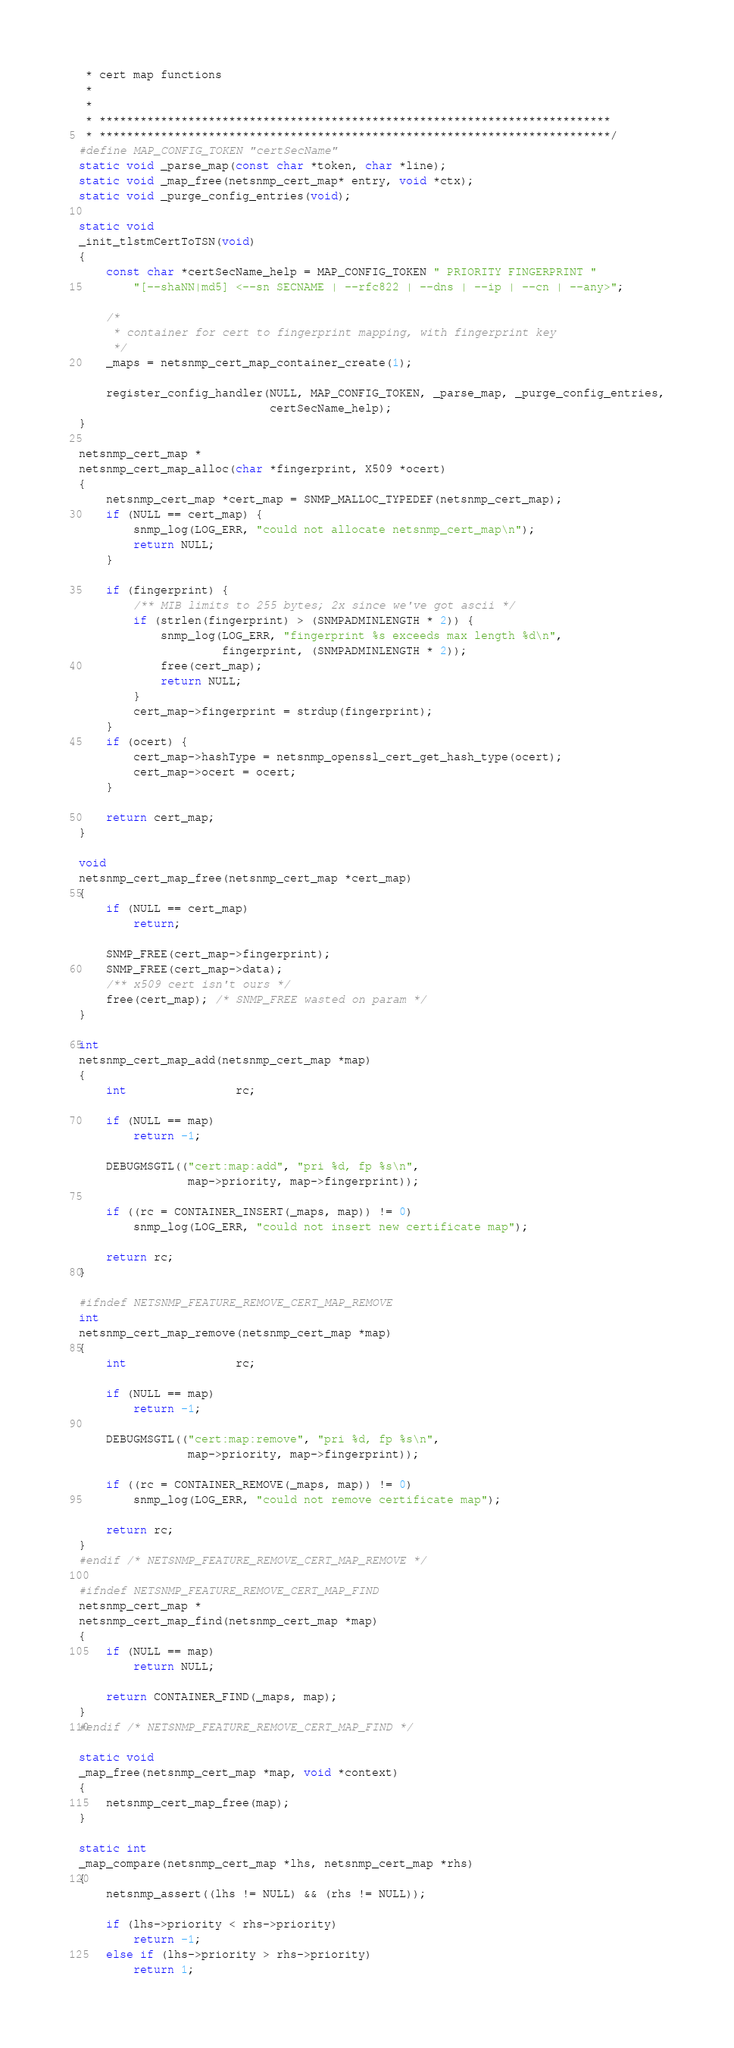Convert code to text. <code><loc_0><loc_0><loc_500><loc_500><_C_> * cert map functions
 *
 *
 * ***************************************************************************
 * ***************************************************************************/
#define MAP_CONFIG_TOKEN "certSecName"
static void _parse_map(const char *token, char *line);
static void _map_free(netsnmp_cert_map* entry, void *ctx);
static void _purge_config_entries(void);

static void
_init_tlstmCertToTSN(void)
{
    const char *certSecName_help = MAP_CONFIG_TOKEN " PRIORITY FINGERPRINT "
        "[--shaNN|md5] <--sn SECNAME | --rfc822 | --dns | --ip | --cn | --any>";

    /*
     * container for cert to fingerprint mapping, with fingerprint key
     */
    _maps = netsnmp_cert_map_container_create(1);

    register_config_handler(NULL, MAP_CONFIG_TOKEN, _parse_map, _purge_config_entries,
                            certSecName_help);
}

netsnmp_cert_map *
netsnmp_cert_map_alloc(char *fingerprint, X509 *ocert)
{
    netsnmp_cert_map *cert_map = SNMP_MALLOC_TYPEDEF(netsnmp_cert_map);
    if (NULL == cert_map) {
        snmp_log(LOG_ERR, "could not allocate netsnmp_cert_map\n");
        return NULL;
    }
    
    if (fingerprint) {
        /** MIB limits to 255 bytes; 2x since we've got ascii */
        if (strlen(fingerprint) > (SNMPADMINLENGTH * 2)) {
            snmp_log(LOG_ERR, "fingerprint %s exceeds max length %d\n",
                     fingerprint, (SNMPADMINLENGTH * 2));
            free(cert_map);
            return NULL;
        }
        cert_map->fingerprint = strdup(fingerprint);
    }
    if (ocert) {
        cert_map->hashType = netsnmp_openssl_cert_get_hash_type(ocert);
        cert_map->ocert = ocert;
    }

    return cert_map;
}

void
netsnmp_cert_map_free(netsnmp_cert_map *cert_map)
{
    if (NULL == cert_map)
        return;

    SNMP_FREE(cert_map->fingerprint);
    SNMP_FREE(cert_map->data);
    /** x509 cert isn't ours */
    free(cert_map); /* SNMP_FREE wasted on param */
}

int
netsnmp_cert_map_add(netsnmp_cert_map *map)
{
    int                rc;

    if (NULL == map)
        return -1;

    DEBUGMSGTL(("cert:map:add", "pri %d, fp %s\n",
                map->priority, map->fingerprint));

    if ((rc = CONTAINER_INSERT(_maps, map)) != 0)
        snmp_log(LOG_ERR, "could not insert new certificate map");

    return rc;
}

#ifndef NETSNMP_FEATURE_REMOVE_CERT_MAP_REMOVE
int
netsnmp_cert_map_remove(netsnmp_cert_map *map)
{
    int                rc;

    if (NULL == map)
        return -1;

    DEBUGMSGTL(("cert:map:remove", "pri %d, fp %s\n",
                map->priority, map->fingerprint));

    if ((rc = CONTAINER_REMOVE(_maps, map)) != 0)
        snmp_log(LOG_ERR, "could not remove certificate map");

    return rc;
}
#endif /* NETSNMP_FEATURE_REMOVE_CERT_MAP_REMOVE */

#ifndef NETSNMP_FEATURE_REMOVE_CERT_MAP_FIND
netsnmp_cert_map *
netsnmp_cert_map_find(netsnmp_cert_map *map)
{
    if (NULL == map)
        return NULL;

    return CONTAINER_FIND(_maps, map);
}
#endif /* NETSNMP_FEATURE_REMOVE_CERT_MAP_FIND */

static void
_map_free(netsnmp_cert_map *map, void *context)
{
    netsnmp_cert_map_free(map);
}

static int
_map_compare(netsnmp_cert_map *lhs, netsnmp_cert_map *rhs)
{
    netsnmp_assert((lhs != NULL) && (rhs != NULL));

    if (lhs->priority < rhs->priority)
        return -1;
    else if (lhs->priority > rhs->priority)
        return 1;
</code> 